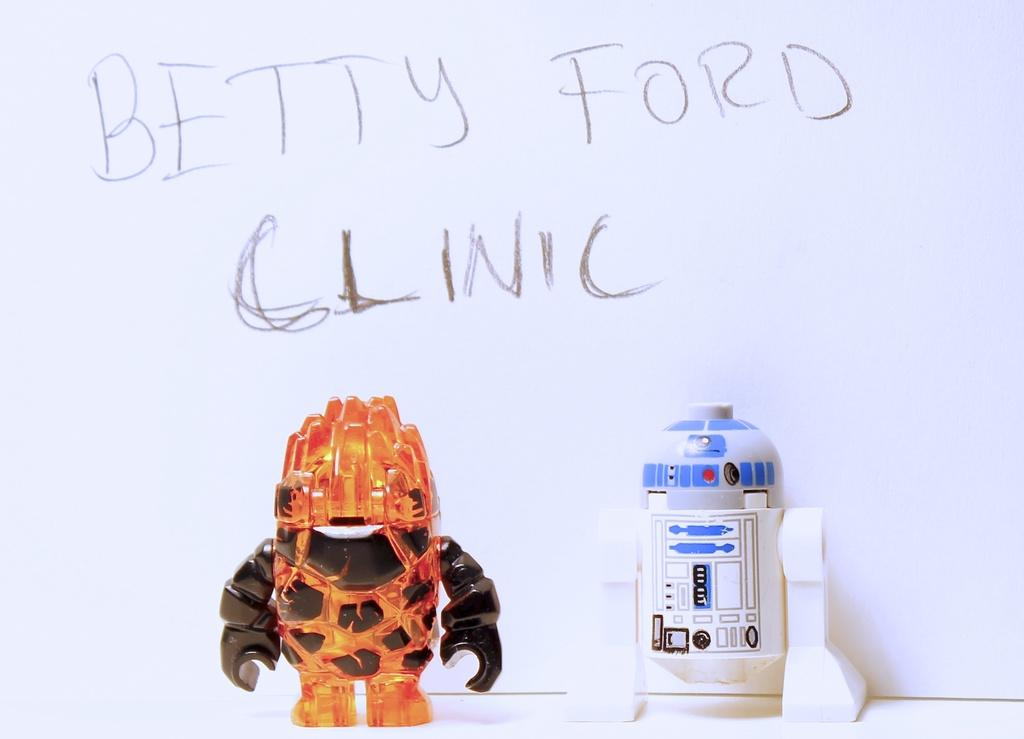How many toys can be seen in the image? There are two toys in the image. Where are the toys located? The toys are placed on a surface. What can be seen in the background of the image? There is a wall with text in the background of the image. How many cherries are on top of the toys in the image? There are no cherries present in the image. Can you compare the size of the toys to the text on the wall in the image? It is not possible to compare the size of the toys to the text on the wall in the image, as the size of the toys is not mentioned in the provided facts. 